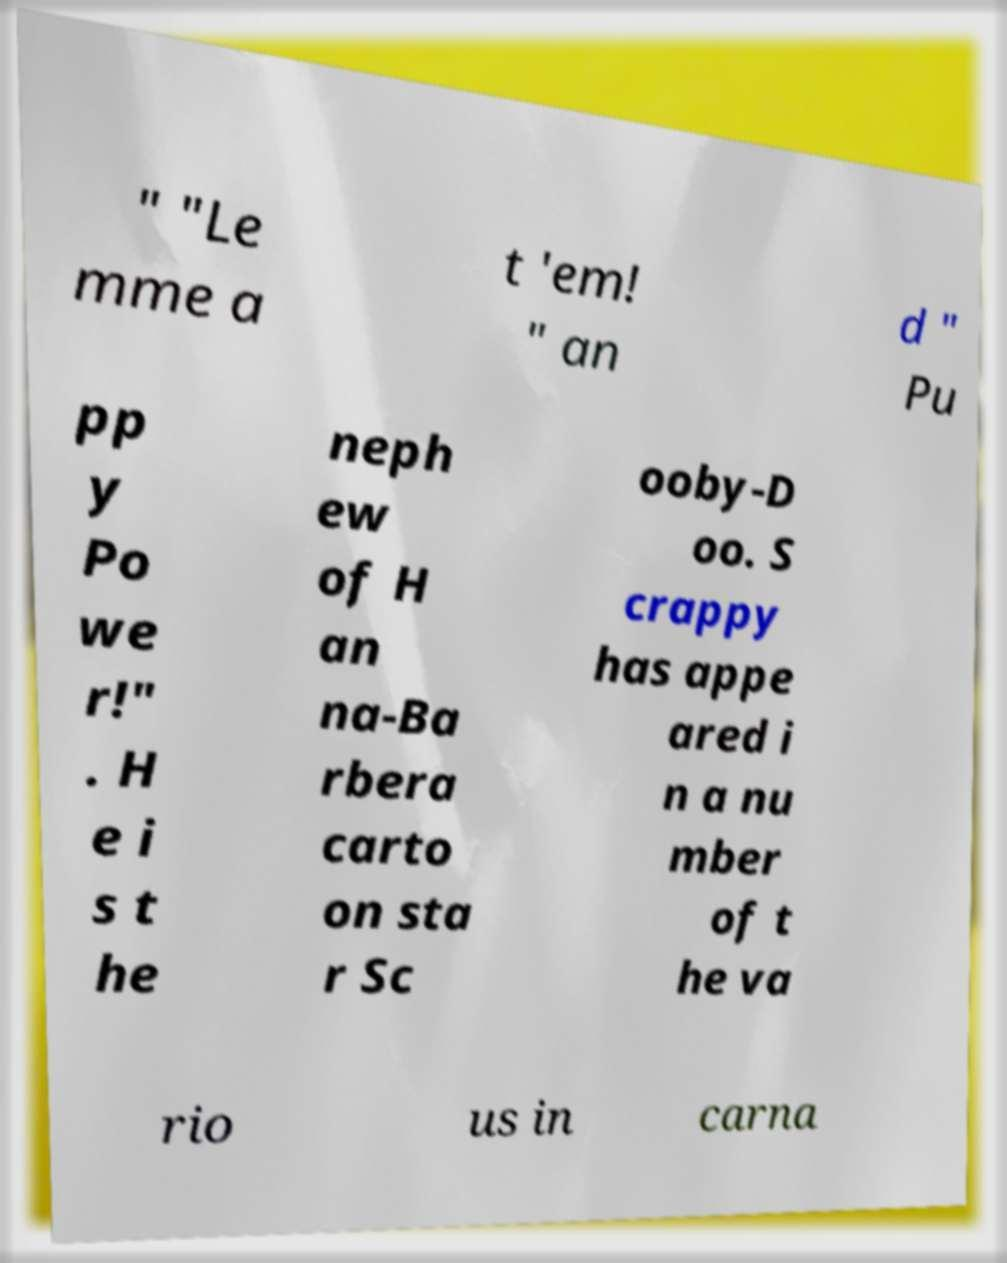I need the written content from this picture converted into text. Can you do that? " "Le mme a t 'em! " an d " Pu pp y Po we r!" . H e i s t he neph ew of H an na-Ba rbera carto on sta r Sc ooby-D oo. S crappy has appe ared i n a nu mber of t he va rio us in carna 